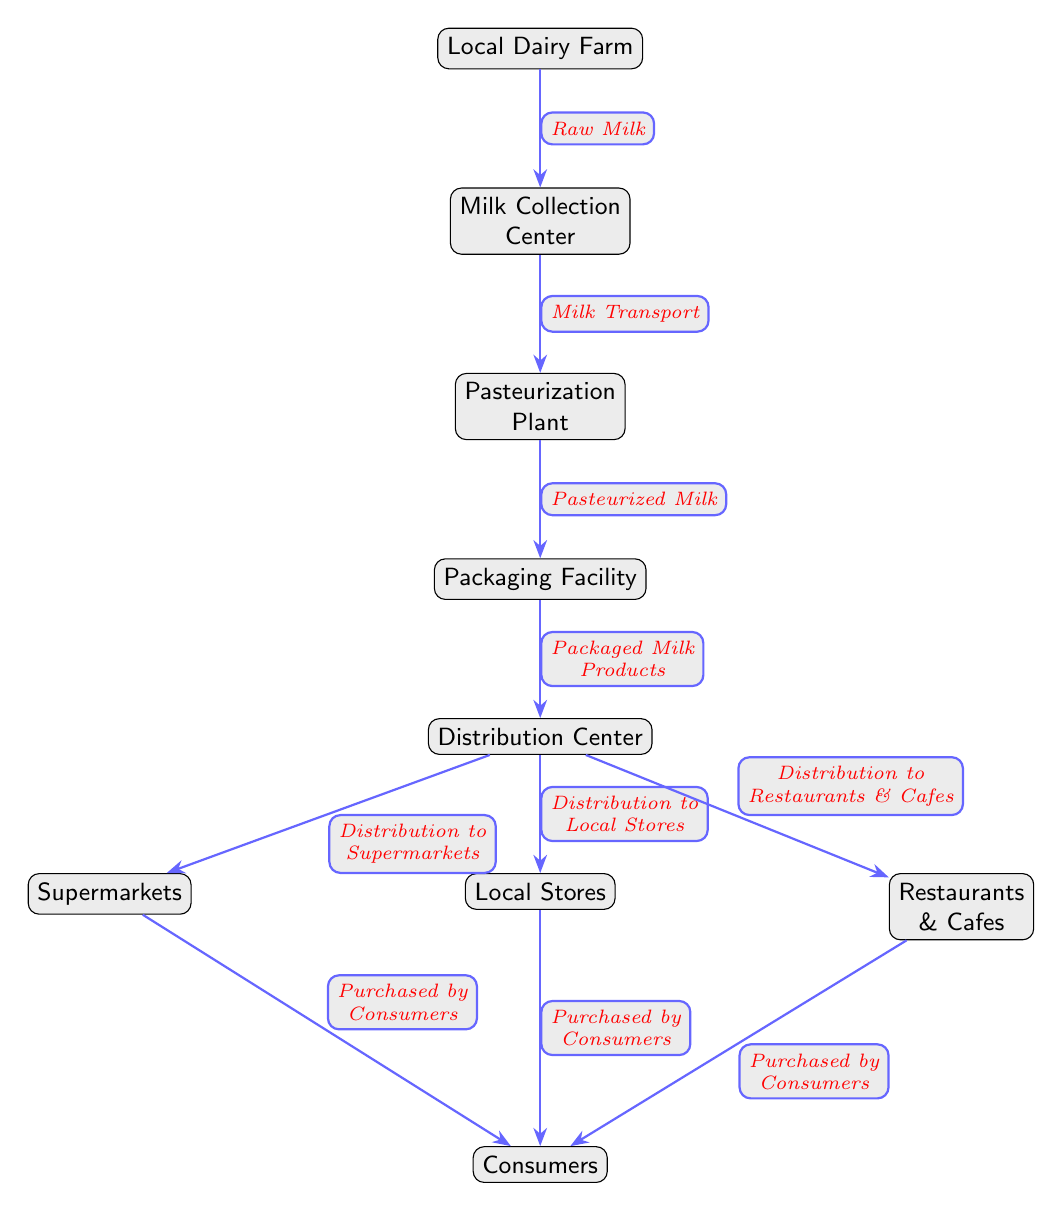What is the first node in the food chain? The first node in the food chain is the "Local Dairy Farm", which is the starting point for the distribution of dairy products.
Answer: Local Dairy Farm How many nodes are there in total? By counting each unique participant in the food chain from the Local Dairy Farm to Consumers, there are a total of 9 nodes in the diagram.
Answer: 9 What type of milk is transported from the Milk Collection Center? Milk is transported as "Raw Milk" from the Local Dairy Farm to the Milk Collection Center, illustrated by the arrow indicating the direction of flow.
Answer: Raw Milk Which node receives packaged milk products? The "Distribution Center" receives the "Packaged Milk Products" from the Packaging Facility, as indicated by the flow of arrows in the diagram.
Answer: Distribution Center How many distribution paths lead to consumers? There are three distribution paths leading to consumers: from Supermarkets, Local Stores, and Restaurants & Cafes, as indicated by separate arrows connecting these nodes to Consumers.
Answer: 3 Where does pasteurized milk go after the Pasteurization Plant? After the Pasteurization Plant, the "Pasteurized Milk" goes to the Packaging Facility, which is connected directly with the arrow showing the flow.
Answer: Packaging Facility Which nodes sell dairy products directly to consumers? The nodes that sell dairy products directly to consumers are Supermarkets, Local Stores, and Restaurants & Cafes, each represented as unique nodes in the diagram.
Answer: Supermarkets, Local Stores, Restaurants & Cafes What is the last stage before consumers purchase dairy products? The last stage before consumers purchase dairy products is the "Distribution Center", which is responsible for distributing products to Supermarkets, Local Stores, and Restaurants & Cafes.
Answer: Distribution Center What processes occur before the milk reaches consumers? Before the milk reaches consumers, it goes through several processes: collection at the Milk Collection Center, pasteurization at the Pasteurization Plant, and packaging at the Packaging Facility. Each step is integral to ensuring the safety and quality of dairy products.
Answer: Collection, Pasteurization, Packaging 